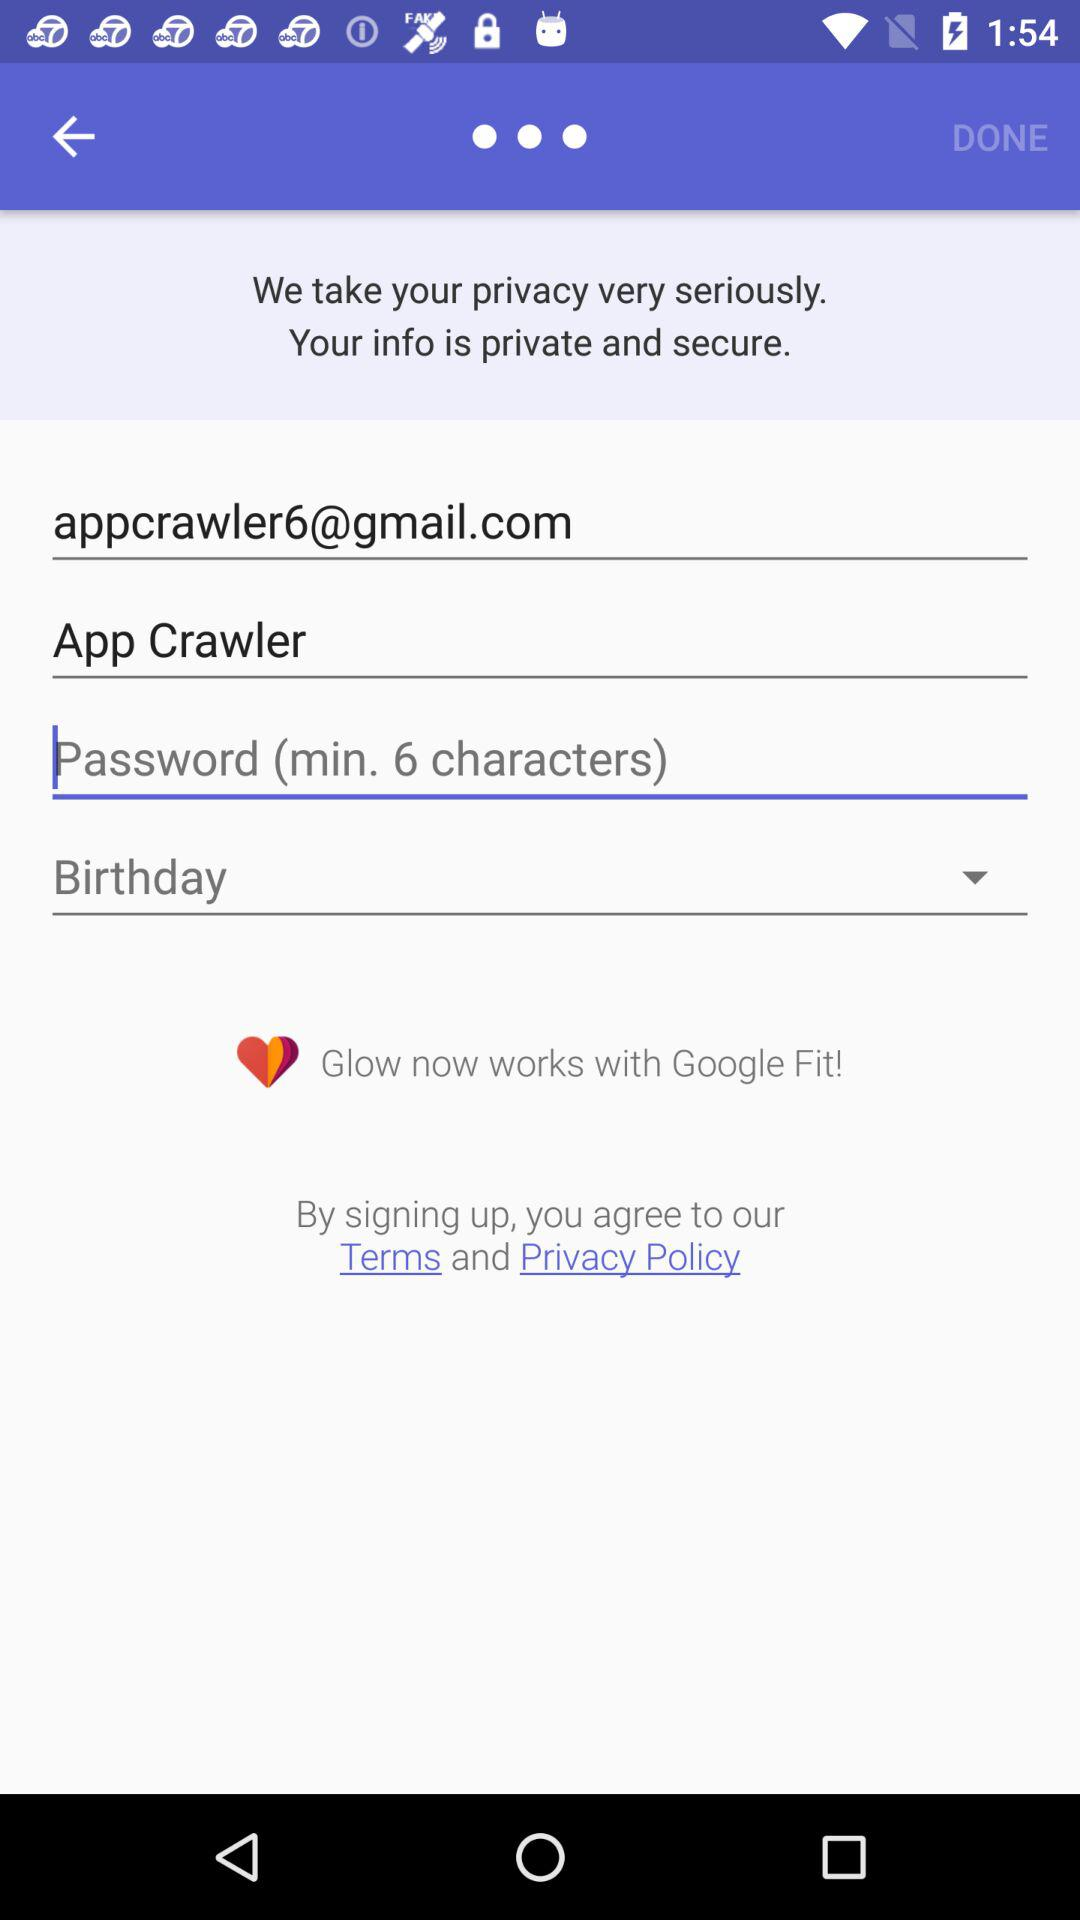What is the given email address? The given email address is appcrawler6@gmail.com. 